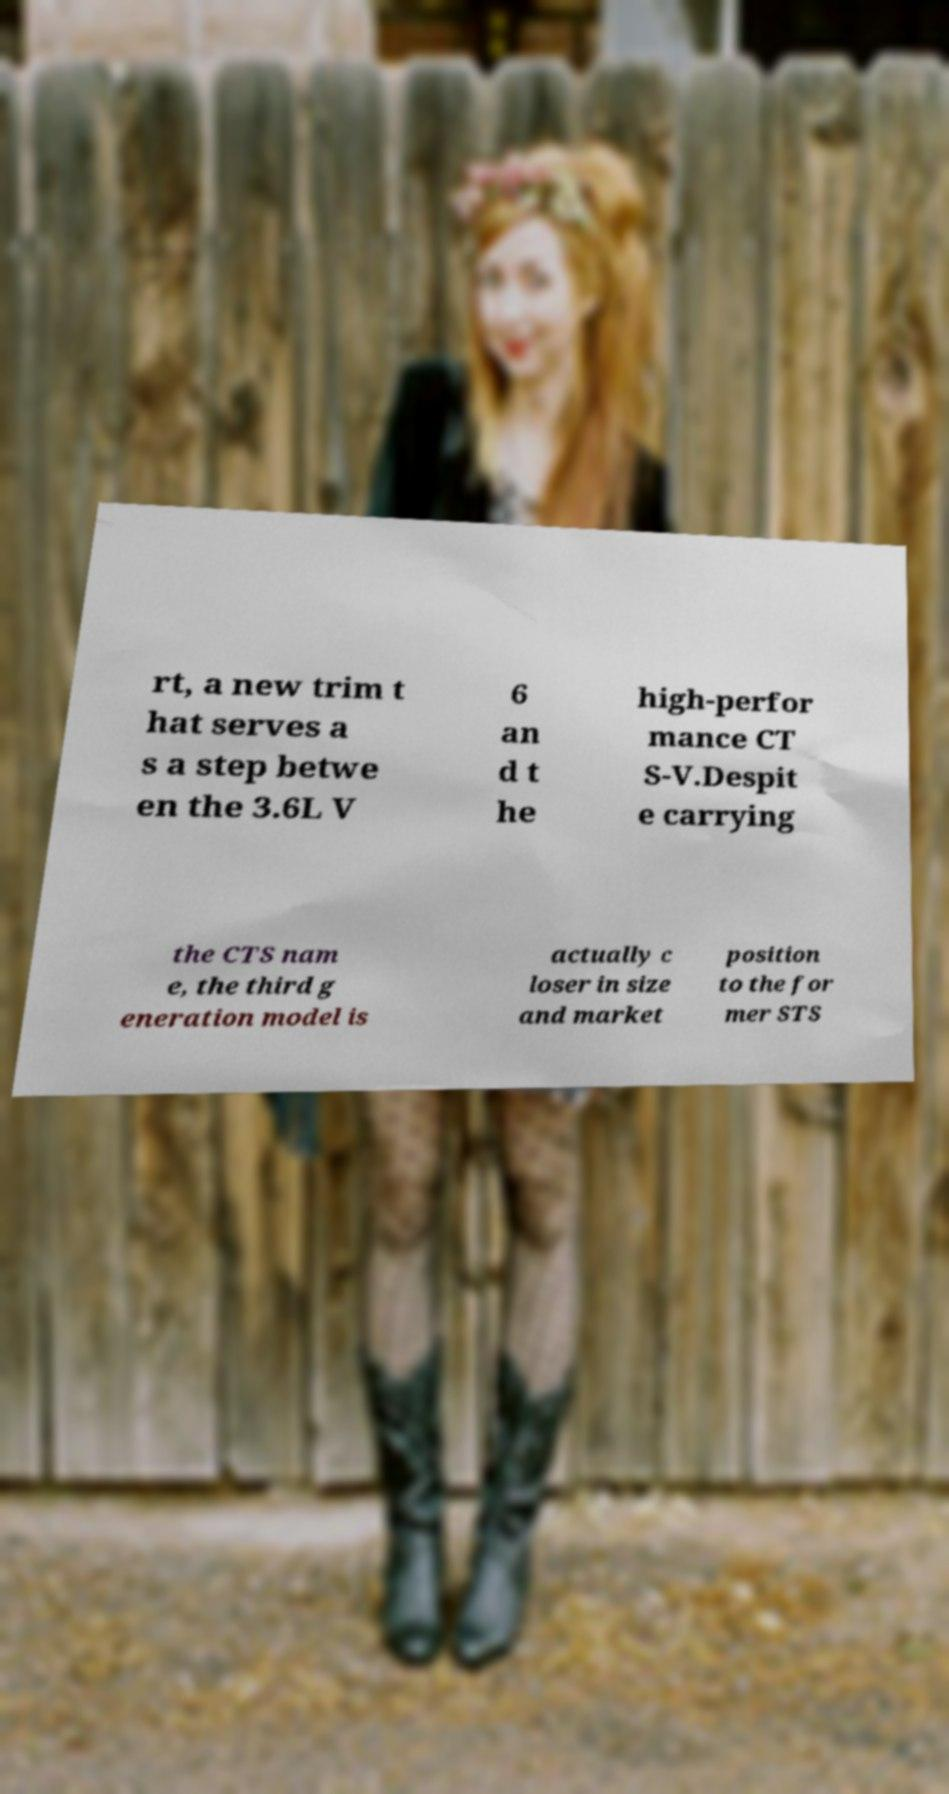Can you accurately transcribe the text from the provided image for me? rt, a new trim t hat serves a s a step betwe en the 3.6L V 6 an d t he high-perfor mance CT S-V.Despit e carrying the CTS nam e, the third g eneration model is actually c loser in size and market position to the for mer STS 